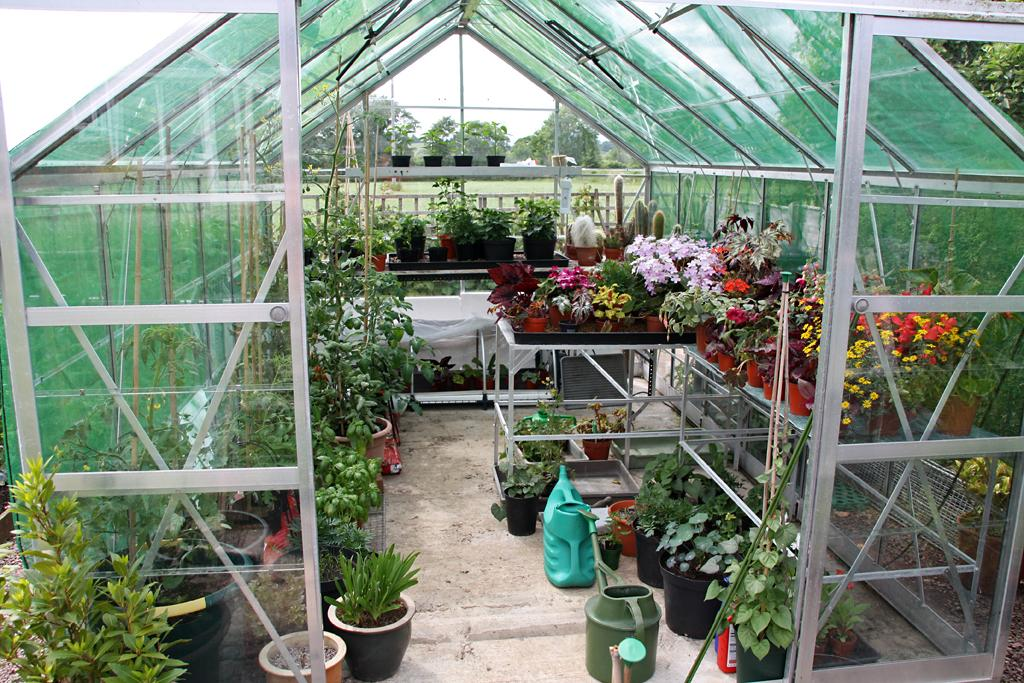What types of plants are visible on the surface in the image? There are flowers and house plants on the surface in the image. Where is the location of the image? The location is described as a shed. What can be seen in the background of the image? There are trees and the sky visible in the background of the image. What type of linen is draped over the flowers in the image? There is no linen present in the image; the flowers are not covered or draped with any fabric. 